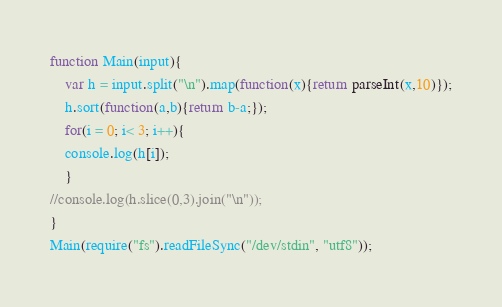Convert code to text. <code><loc_0><loc_0><loc_500><loc_500><_JavaScript_>function Main(input){
    var h = input.split("\n").map(function(x){return parseInt(x,10)});
    h.sort(function(a,b){return b-a;});
    for(i = 0; i< 3; i++){
	console.log(h[i]);
    }
//console.log(h.slice(0,3).join("\n"));
}
Main(require("fs").readFileSync("/dev/stdin", "utf8"));</code> 